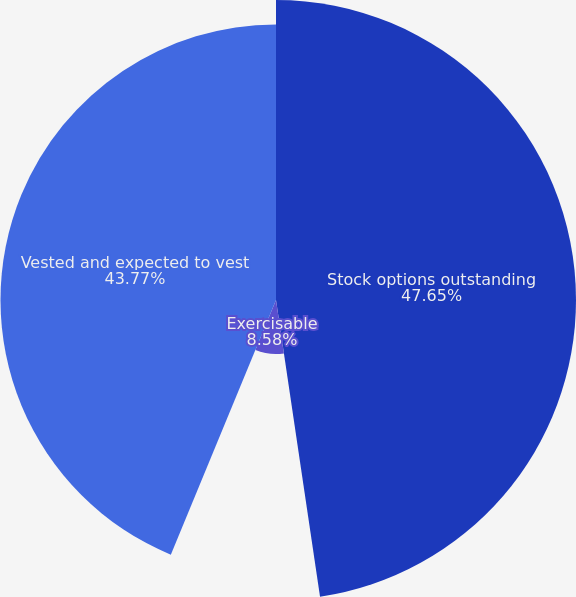Convert chart. <chart><loc_0><loc_0><loc_500><loc_500><pie_chart><fcel>Stock options outstanding<fcel>Exercisable<fcel>Vested and expected to vest<nl><fcel>47.66%<fcel>8.58%<fcel>43.77%<nl></chart> 